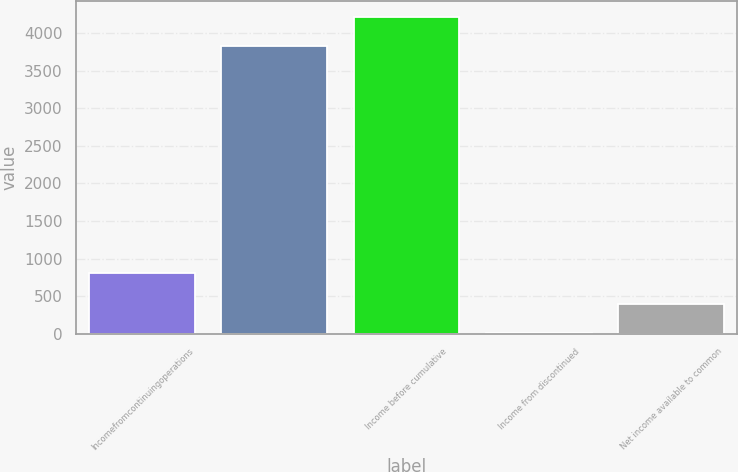Convert chart to OTSL. <chart><loc_0><loc_0><loc_500><loc_500><bar_chart><fcel>Incomefromcontinuingoperations<fcel>Unnamed: 1<fcel>Income before cumulative<fcel>Income from discontinued<fcel>Net income available to common<nl><fcel>806<fcel>3829<fcel>4214.9<fcel>4.02<fcel>389.92<nl></chart> 